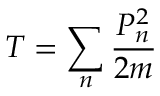<formula> <loc_0><loc_0><loc_500><loc_500>T = \sum _ { n } { \frac { P _ { n } ^ { 2 } } { 2 m } }</formula> 